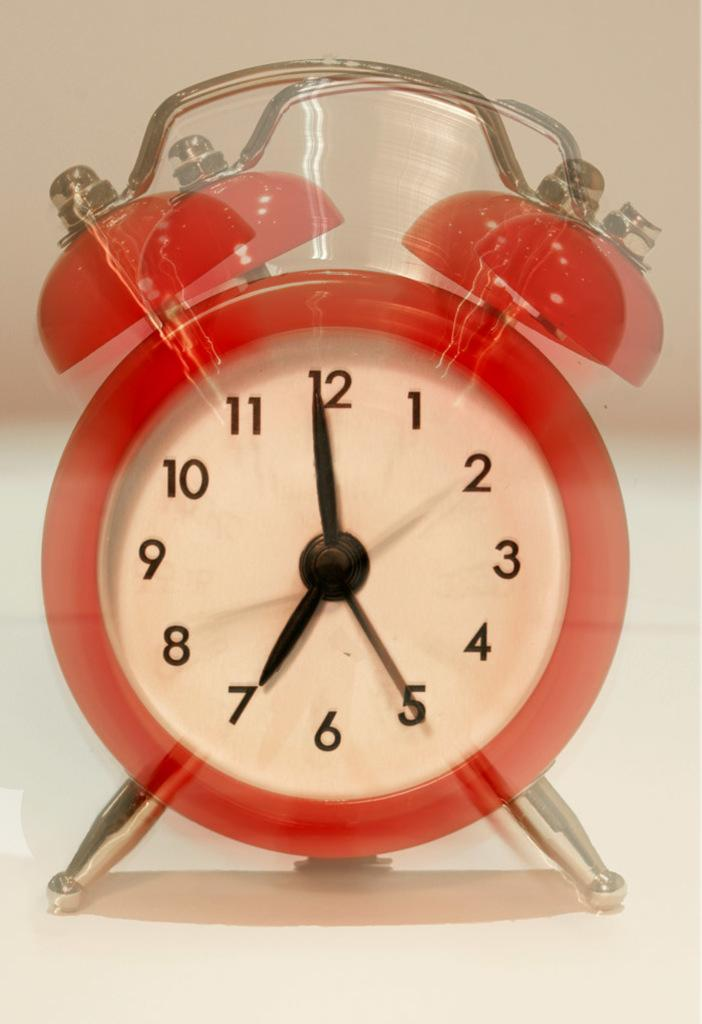Provide a one-sentence caption for the provided image. A red alarm clock with a white face and black numbers reads 6:58. 